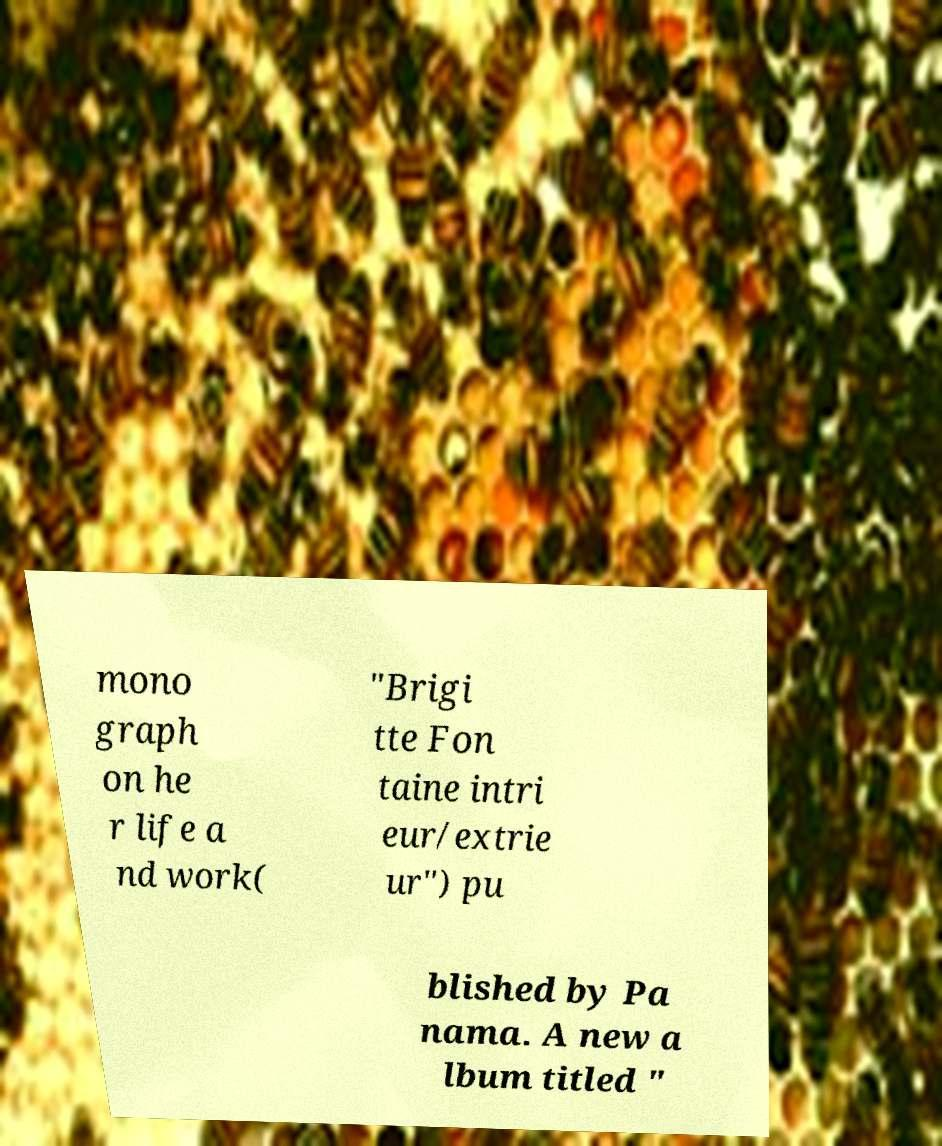Could you extract and type out the text from this image? mono graph on he r life a nd work( "Brigi tte Fon taine intri eur/extrie ur") pu blished by Pa nama. A new a lbum titled " 